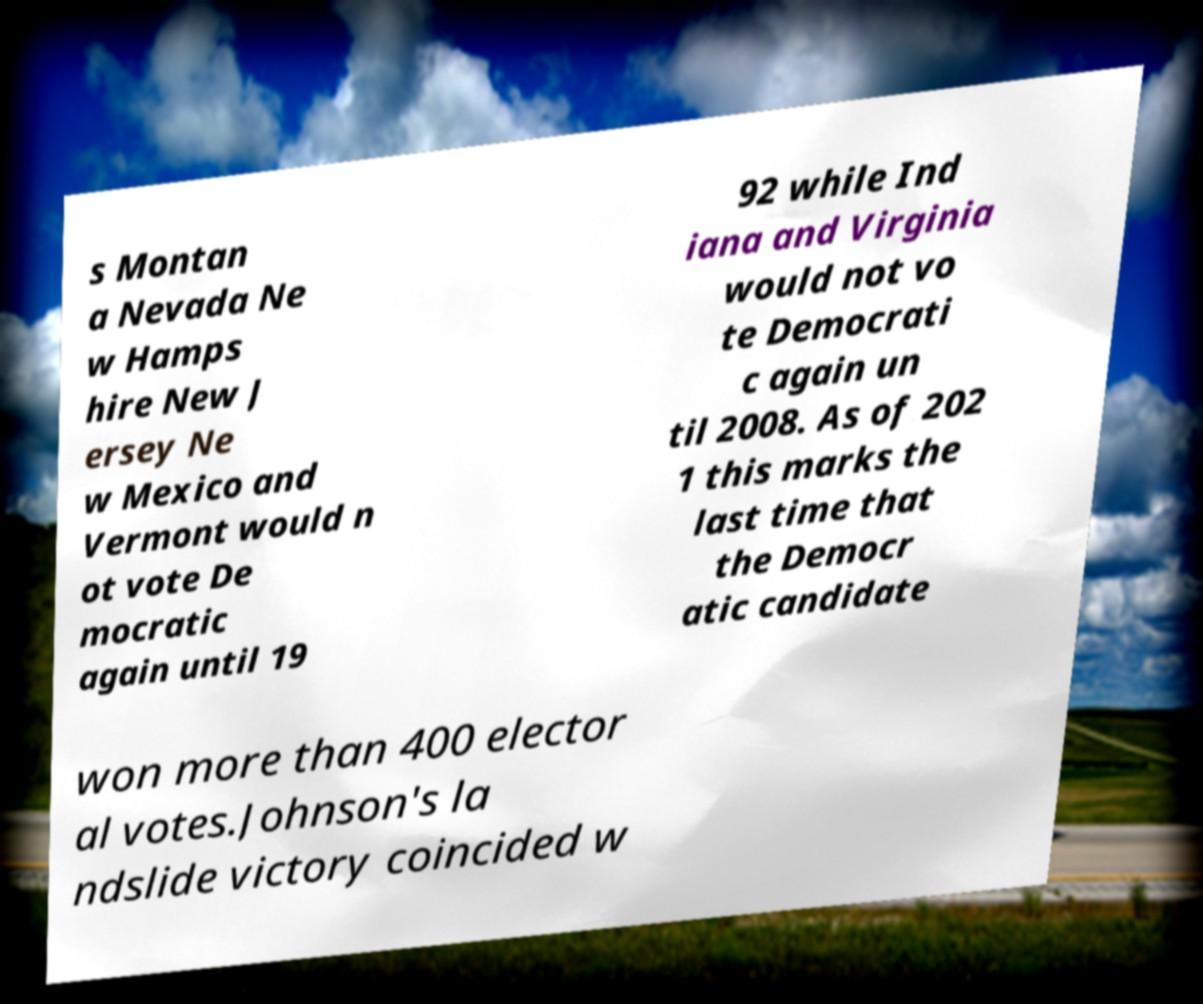Please read and relay the text visible in this image. What does it say? s Montan a Nevada Ne w Hamps hire New J ersey Ne w Mexico and Vermont would n ot vote De mocratic again until 19 92 while Ind iana and Virginia would not vo te Democrati c again un til 2008. As of 202 1 this marks the last time that the Democr atic candidate won more than 400 elector al votes.Johnson's la ndslide victory coincided w 